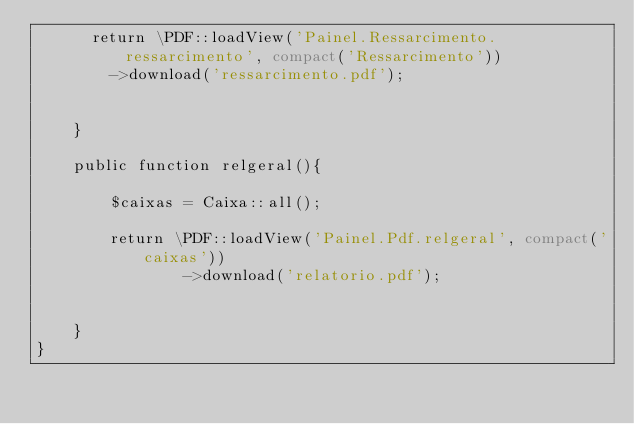<code> <loc_0><loc_0><loc_500><loc_500><_PHP_>    	return \PDF::loadView('Painel.Ressarcimento.ressarcimento', compact('Ressarcimento'))
    		->download('ressarcimento.pdf');


    }

    public function relgeral(){

        $caixas = Caixa::all();
        
        return \PDF::loadView('Painel.Pdf.relgeral', compact('caixas'))
                ->download('relatorio.pdf');


    }
}
</code> 